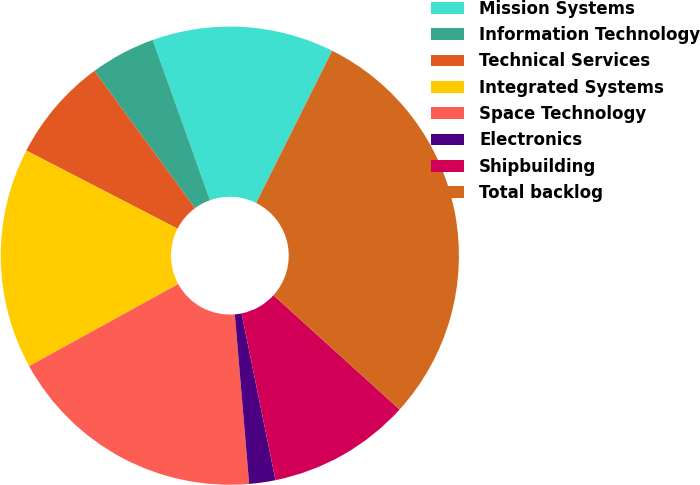Convert chart. <chart><loc_0><loc_0><loc_500><loc_500><pie_chart><fcel>Mission Systems<fcel>Information Technology<fcel>Technical Services<fcel>Integrated Systems<fcel>Space Technology<fcel>Electronics<fcel>Shipbuilding<fcel>Total backlog<nl><fcel>12.84%<fcel>4.6%<fcel>7.35%<fcel>15.59%<fcel>18.34%<fcel>1.85%<fcel>10.09%<fcel>29.34%<nl></chart> 